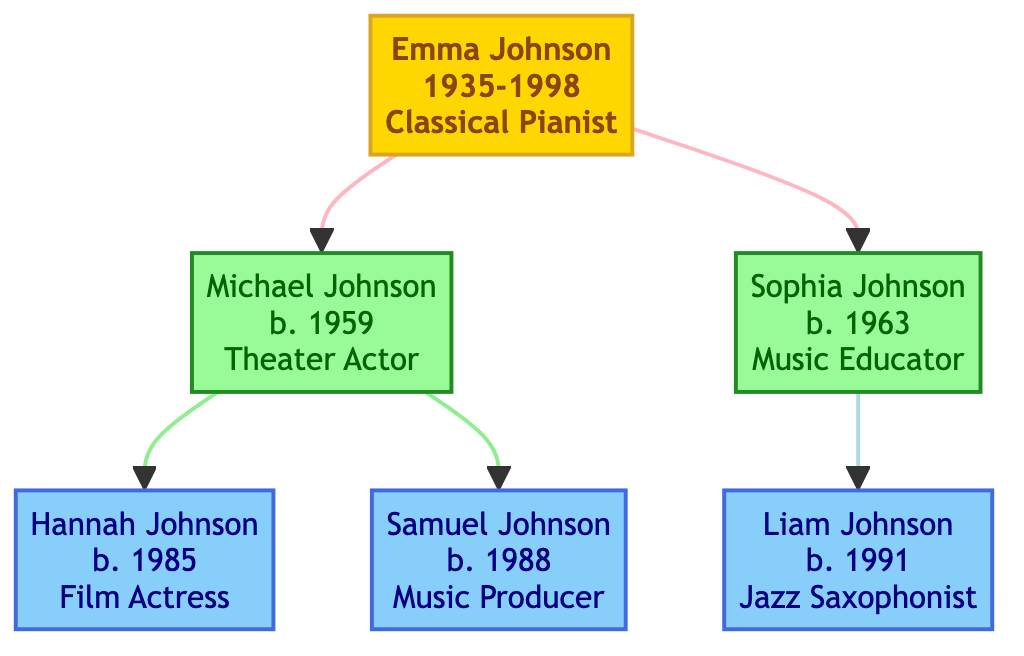What is the profession of Emma Johnson? Emma Johnson is identified in the diagram as a "Classical Pianist" under the ancestor node.
Answer: Classical Pianist How many descendants does Michael Johnson have? Michael Johnson has two descendants listed; they are Hannah Johnson and Samuel Johnson.
Answer: 2 Who is the father of Liam Johnson? In the family tree, Liam Johnson is a descendant of Sophia Johnson, who is Michael Johnson's sister, making Michael Johnson Liam's uncle. Thus, the question focuses on Sophia Johnson as the direct parent.
Answer: Sophia Johnson What was the main contribution of Sophia Johnson? The diagram states that Sophia Johnson founded a community music school focused on underprivileged youth, highlighting her contributions as a music educator.
Answer: Founder of a community music school Which profession is shared by the descendants of Michael Johnson? Among Michael Johnson's descendants, both Hannah Johnson and Samuel Johnson have careers in the arts, specifically acting and music, respectively. However, only Hannah Johnson has the direct profession of "Film Actress."
Answer: Film Actress How many generations are there in this family tree? The family tree consists of three generations: the ancestor Emma Johnson, her children (Michael and Sophia), and their respective children (Hannah, Samuel, and Liam).
Answer: 3 What is the birth year of Samuel Johnson? The diagram shows that Samuel Johnson was born in 1988, providing a clear data point regarding his birth year.
Answer: 1988 Which branch of the family includes a Music Producer? Within the family tree, the branch of Michael Johnson includes Samuel Johnson, who is identified as a Music Producer in the diagram.
Answer: Michael Johnson's branch Who taught at the Juilliard School? Emma Johnson, the ancestor in the diagram, is noted for having taught at the Juilliard School, combining her role as a performer and educator.
Answer: Emma Johnson 